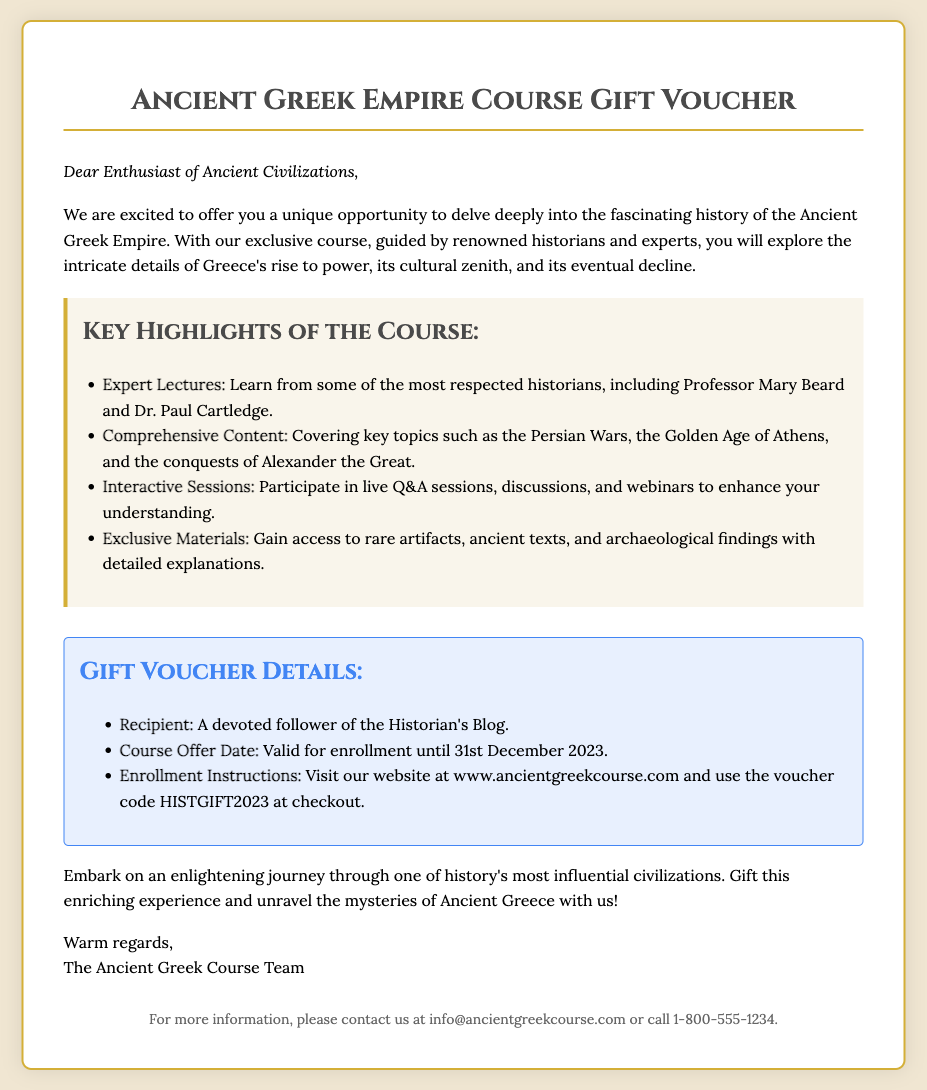What is the title of the course? The title of the course is stated at the top of the document.
Answer: Ancient Greek Empire Course Gift Voucher Who is the recipient of the gift voucher? The recipient is mentioned under the gift details section.
Answer: A devoted follower of the Historian's Blog What is the voucher code for enrollment? The voucher code is provided in the gift details section for use at checkout.
Answer: HISTGIFT2023 What is the validity date for the course offer? The validity date is explicitly mentioned in the gift details.
Answer: 31st December 2023 Who is one of the expert lecturers in the course? The names of expert lecturers are listed under key highlights in the document.
Answer: Professor Mary Beard What type of sessions does the course include? The document highlights specific types of interactive components of the course.
Answer: Interactive Sessions What should you visit to enroll in the course? The document specifies where to go for enrollment in the gift details section.
Answer: www.ancientgreekcourse.com How can you contact the course team for more information? The contact information is provided at the bottom of the document.
Answer: info@ancientgreekcourse.com 